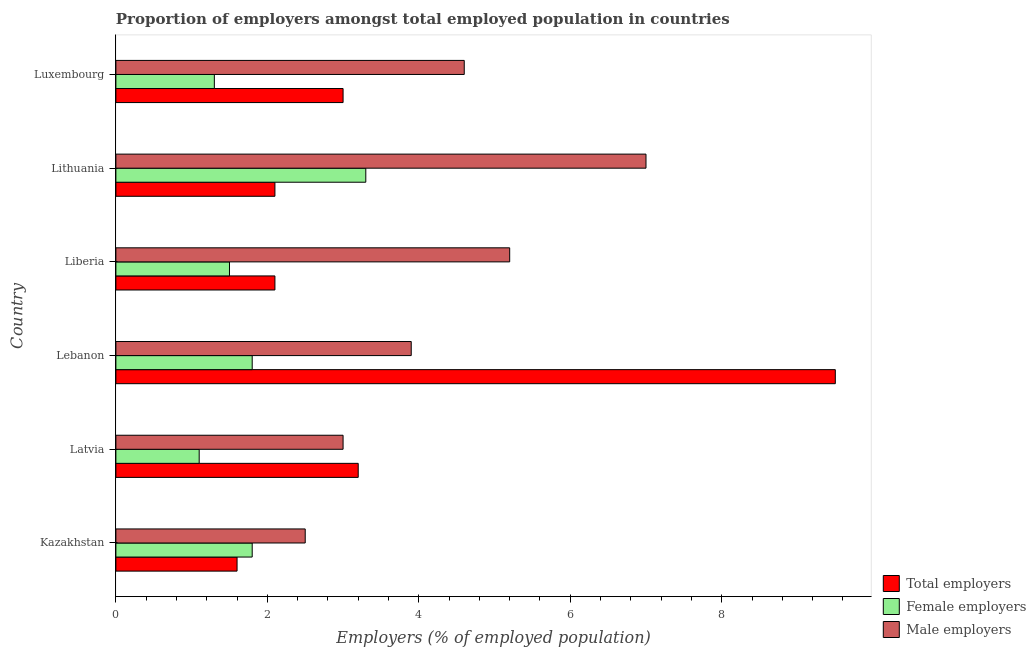How many different coloured bars are there?
Your answer should be compact. 3. Are the number of bars per tick equal to the number of legend labels?
Provide a succinct answer. Yes. Are the number of bars on each tick of the Y-axis equal?
Give a very brief answer. Yes. How many bars are there on the 4th tick from the top?
Give a very brief answer. 3. How many bars are there on the 3rd tick from the bottom?
Your answer should be compact. 3. What is the label of the 6th group of bars from the top?
Give a very brief answer. Kazakhstan. In how many cases, is the number of bars for a given country not equal to the number of legend labels?
Ensure brevity in your answer.  0. What is the percentage of total employers in Kazakhstan?
Your answer should be very brief. 1.6. Across all countries, what is the minimum percentage of male employers?
Offer a terse response. 2.5. In which country was the percentage of female employers maximum?
Keep it short and to the point. Lithuania. In which country was the percentage of female employers minimum?
Your response must be concise. Latvia. What is the total percentage of total employers in the graph?
Offer a terse response. 21.5. What is the difference between the percentage of total employers in Luxembourg and the percentage of male employers in Liberia?
Make the answer very short. -2.2. In how many countries, is the percentage of total employers greater than 7.6 %?
Ensure brevity in your answer.  1. What is the ratio of the percentage of total employers in Kazakhstan to that in Lebanon?
Offer a terse response. 0.17. Is the difference between the percentage of male employers in Liberia and Lithuania greater than the difference between the percentage of female employers in Liberia and Lithuania?
Provide a short and direct response. No. What is the difference between the highest and the second highest percentage of total employers?
Provide a short and direct response. 6.3. What is the difference between the highest and the lowest percentage of female employers?
Offer a very short reply. 2.2. What does the 2nd bar from the top in Lebanon represents?
Make the answer very short. Female employers. What does the 3rd bar from the bottom in Lithuania represents?
Ensure brevity in your answer.  Male employers. Are all the bars in the graph horizontal?
Keep it short and to the point. Yes. Does the graph contain any zero values?
Offer a terse response. No. Where does the legend appear in the graph?
Your answer should be compact. Bottom right. How many legend labels are there?
Make the answer very short. 3. How are the legend labels stacked?
Keep it short and to the point. Vertical. What is the title of the graph?
Ensure brevity in your answer.  Proportion of employers amongst total employed population in countries. What is the label or title of the X-axis?
Make the answer very short. Employers (% of employed population). What is the Employers (% of employed population) of Total employers in Kazakhstan?
Make the answer very short. 1.6. What is the Employers (% of employed population) of Female employers in Kazakhstan?
Give a very brief answer. 1.8. What is the Employers (% of employed population) of Total employers in Latvia?
Your response must be concise. 3.2. What is the Employers (% of employed population) in Female employers in Latvia?
Keep it short and to the point. 1.1. What is the Employers (% of employed population) in Total employers in Lebanon?
Ensure brevity in your answer.  9.5. What is the Employers (% of employed population) in Female employers in Lebanon?
Offer a terse response. 1.8. What is the Employers (% of employed population) of Male employers in Lebanon?
Your response must be concise. 3.9. What is the Employers (% of employed population) of Total employers in Liberia?
Your response must be concise. 2.1. What is the Employers (% of employed population) of Male employers in Liberia?
Your answer should be very brief. 5.2. What is the Employers (% of employed population) in Total employers in Lithuania?
Make the answer very short. 2.1. What is the Employers (% of employed population) in Female employers in Lithuania?
Provide a succinct answer. 3.3. What is the Employers (% of employed population) of Male employers in Lithuania?
Your response must be concise. 7. What is the Employers (% of employed population) in Female employers in Luxembourg?
Provide a short and direct response. 1.3. What is the Employers (% of employed population) of Male employers in Luxembourg?
Ensure brevity in your answer.  4.6. Across all countries, what is the maximum Employers (% of employed population) in Total employers?
Ensure brevity in your answer.  9.5. Across all countries, what is the maximum Employers (% of employed population) of Female employers?
Ensure brevity in your answer.  3.3. Across all countries, what is the minimum Employers (% of employed population) of Total employers?
Provide a short and direct response. 1.6. Across all countries, what is the minimum Employers (% of employed population) of Female employers?
Offer a very short reply. 1.1. Across all countries, what is the minimum Employers (% of employed population) of Male employers?
Give a very brief answer. 2.5. What is the total Employers (% of employed population) of Male employers in the graph?
Your answer should be very brief. 26.2. What is the difference between the Employers (% of employed population) in Total employers in Kazakhstan and that in Latvia?
Make the answer very short. -1.6. What is the difference between the Employers (% of employed population) in Total employers in Kazakhstan and that in Lebanon?
Your answer should be compact. -7.9. What is the difference between the Employers (% of employed population) in Female employers in Kazakhstan and that in Lebanon?
Ensure brevity in your answer.  0. What is the difference between the Employers (% of employed population) in Male employers in Kazakhstan and that in Lebanon?
Your response must be concise. -1.4. What is the difference between the Employers (% of employed population) of Female employers in Kazakhstan and that in Liberia?
Give a very brief answer. 0.3. What is the difference between the Employers (% of employed population) in Total employers in Kazakhstan and that in Lithuania?
Give a very brief answer. -0.5. What is the difference between the Employers (% of employed population) of Female employers in Kazakhstan and that in Lithuania?
Your answer should be very brief. -1.5. What is the difference between the Employers (% of employed population) of Total employers in Kazakhstan and that in Luxembourg?
Provide a short and direct response. -1.4. What is the difference between the Employers (% of employed population) of Female employers in Latvia and that in Lebanon?
Your response must be concise. -0.7. What is the difference between the Employers (% of employed population) of Male employers in Latvia and that in Lebanon?
Offer a terse response. -0.9. What is the difference between the Employers (% of employed population) of Total employers in Latvia and that in Liberia?
Keep it short and to the point. 1.1. What is the difference between the Employers (% of employed population) of Female employers in Latvia and that in Liberia?
Provide a short and direct response. -0.4. What is the difference between the Employers (% of employed population) of Male employers in Latvia and that in Liberia?
Your answer should be very brief. -2.2. What is the difference between the Employers (% of employed population) of Female employers in Latvia and that in Lithuania?
Your answer should be very brief. -2.2. What is the difference between the Employers (% of employed population) of Male employers in Latvia and that in Lithuania?
Your answer should be compact. -4. What is the difference between the Employers (% of employed population) of Total employers in Latvia and that in Luxembourg?
Make the answer very short. 0.2. What is the difference between the Employers (% of employed population) in Male employers in Latvia and that in Luxembourg?
Your response must be concise. -1.6. What is the difference between the Employers (% of employed population) of Total employers in Lebanon and that in Lithuania?
Keep it short and to the point. 7.4. What is the difference between the Employers (% of employed population) in Female employers in Lebanon and that in Lithuania?
Your response must be concise. -1.5. What is the difference between the Employers (% of employed population) in Male employers in Lebanon and that in Lithuania?
Ensure brevity in your answer.  -3.1. What is the difference between the Employers (% of employed population) of Total employers in Lebanon and that in Luxembourg?
Keep it short and to the point. 6.5. What is the difference between the Employers (% of employed population) of Total employers in Liberia and that in Lithuania?
Offer a very short reply. 0. What is the difference between the Employers (% of employed population) of Female employers in Liberia and that in Luxembourg?
Give a very brief answer. 0.2. What is the difference between the Employers (% of employed population) of Male employers in Liberia and that in Luxembourg?
Give a very brief answer. 0.6. What is the difference between the Employers (% of employed population) of Male employers in Lithuania and that in Luxembourg?
Your answer should be compact. 2.4. What is the difference between the Employers (% of employed population) of Total employers in Kazakhstan and the Employers (% of employed population) of Female employers in Latvia?
Make the answer very short. 0.5. What is the difference between the Employers (% of employed population) in Total employers in Kazakhstan and the Employers (% of employed population) in Male employers in Latvia?
Your response must be concise. -1.4. What is the difference between the Employers (% of employed population) of Female employers in Kazakhstan and the Employers (% of employed population) of Male employers in Latvia?
Your answer should be very brief. -1.2. What is the difference between the Employers (% of employed population) in Total employers in Kazakhstan and the Employers (% of employed population) in Female employers in Lebanon?
Make the answer very short. -0.2. What is the difference between the Employers (% of employed population) in Total employers in Kazakhstan and the Employers (% of employed population) in Female employers in Liberia?
Keep it short and to the point. 0.1. What is the difference between the Employers (% of employed population) of Female employers in Kazakhstan and the Employers (% of employed population) of Male employers in Liberia?
Make the answer very short. -3.4. What is the difference between the Employers (% of employed population) in Total employers in Kazakhstan and the Employers (% of employed population) in Female employers in Lithuania?
Provide a succinct answer. -1.7. What is the difference between the Employers (% of employed population) in Total employers in Kazakhstan and the Employers (% of employed population) in Female employers in Luxembourg?
Give a very brief answer. 0.3. What is the difference between the Employers (% of employed population) of Female employers in Kazakhstan and the Employers (% of employed population) of Male employers in Luxembourg?
Your response must be concise. -2.8. What is the difference between the Employers (% of employed population) of Total employers in Latvia and the Employers (% of employed population) of Male employers in Lebanon?
Provide a short and direct response. -0.7. What is the difference between the Employers (% of employed population) in Total employers in Latvia and the Employers (% of employed population) in Female employers in Lithuania?
Your response must be concise. -0.1. What is the difference between the Employers (% of employed population) in Total employers in Latvia and the Employers (% of employed population) in Male employers in Lithuania?
Ensure brevity in your answer.  -3.8. What is the difference between the Employers (% of employed population) of Female employers in Latvia and the Employers (% of employed population) of Male employers in Luxembourg?
Your answer should be compact. -3.5. What is the difference between the Employers (% of employed population) in Female employers in Lebanon and the Employers (% of employed population) in Male employers in Liberia?
Provide a succinct answer. -3.4. What is the difference between the Employers (% of employed population) in Total employers in Lebanon and the Employers (% of employed population) in Female employers in Lithuania?
Make the answer very short. 6.2. What is the difference between the Employers (% of employed population) in Total employers in Lebanon and the Employers (% of employed population) in Male employers in Lithuania?
Provide a succinct answer. 2.5. What is the difference between the Employers (% of employed population) in Female employers in Lebanon and the Employers (% of employed population) in Male employers in Lithuania?
Keep it short and to the point. -5.2. What is the difference between the Employers (% of employed population) in Total employers in Lebanon and the Employers (% of employed population) in Female employers in Luxembourg?
Make the answer very short. 8.2. What is the difference between the Employers (% of employed population) of Total employers in Lebanon and the Employers (% of employed population) of Male employers in Luxembourg?
Your response must be concise. 4.9. What is the difference between the Employers (% of employed population) of Female employers in Lebanon and the Employers (% of employed population) of Male employers in Luxembourg?
Make the answer very short. -2.8. What is the difference between the Employers (% of employed population) of Total employers in Liberia and the Employers (% of employed population) of Male employers in Lithuania?
Give a very brief answer. -4.9. What is the difference between the Employers (% of employed population) in Total employers in Liberia and the Employers (% of employed population) in Female employers in Luxembourg?
Give a very brief answer. 0.8. What is the difference between the Employers (% of employed population) in Total employers in Lithuania and the Employers (% of employed population) in Female employers in Luxembourg?
Offer a terse response. 0.8. What is the difference between the Employers (% of employed population) of Total employers in Lithuania and the Employers (% of employed population) of Male employers in Luxembourg?
Keep it short and to the point. -2.5. What is the difference between the Employers (% of employed population) in Female employers in Lithuania and the Employers (% of employed population) in Male employers in Luxembourg?
Ensure brevity in your answer.  -1.3. What is the average Employers (% of employed population) of Total employers per country?
Your answer should be very brief. 3.58. What is the average Employers (% of employed population) of Female employers per country?
Ensure brevity in your answer.  1.8. What is the average Employers (% of employed population) of Male employers per country?
Provide a succinct answer. 4.37. What is the difference between the Employers (% of employed population) of Total employers and Employers (% of employed population) of Female employers in Kazakhstan?
Keep it short and to the point. -0.2. What is the difference between the Employers (% of employed population) in Female employers and Employers (% of employed population) in Male employers in Kazakhstan?
Offer a very short reply. -0.7. What is the difference between the Employers (% of employed population) in Total employers and Employers (% of employed population) in Male employers in Latvia?
Provide a short and direct response. 0.2. What is the difference between the Employers (% of employed population) in Female employers and Employers (% of employed population) in Male employers in Latvia?
Provide a succinct answer. -1.9. What is the difference between the Employers (% of employed population) in Total employers and Employers (% of employed population) in Male employers in Lithuania?
Your response must be concise. -4.9. What is the difference between the Employers (% of employed population) of Female employers and Employers (% of employed population) of Male employers in Lithuania?
Offer a terse response. -3.7. What is the difference between the Employers (% of employed population) of Total employers and Employers (% of employed population) of Female employers in Luxembourg?
Make the answer very short. 1.7. What is the difference between the Employers (% of employed population) in Female employers and Employers (% of employed population) in Male employers in Luxembourg?
Give a very brief answer. -3.3. What is the ratio of the Employers (% of employed population) in Total employers in Kazakhstan to that in Latvia?
Provide a short and direct response. 0.5. What is the ratio of the Employers (% of employed population) of Female employers in Kazakhstan to that in Latvia?
Provide a short and direct response. 1.64. What is the ratio of the Employers (% of employed population) in Total employers in Kazakhstan to that in Lebanon?
Provide a short and direct response. 0.17. What is the ratio of the Employers (% of employed population) of Female employers in Kazakhstan to that in Lebanon?
Keep it short and to the point. 1. What is the ratio of the Employers (% of employed population) of Male employers in Kazakhstan to that in Lebanon?
Your response must be concise. 0.64. What is the ratio of the Employers (% of employed population) of Total employers in Kazakhstan to that in Liberia?
Offer a very short reply. 0.76. What is the ratio of the Employers (% of employed population) in Female employers in Kazakhstan to that in Liberia?
Your answer should be very brief. 1.2. What is the ratio of the Employers (% of employed population) in Male employers in Kazakhstan to that in Liberia?
Give a very brief answer. 0.48. What is the ratio of the Employers (% of employed population) in Total employers in Kazakhstan to that in Lithuania?
Give a very brief answer. 0.76. What is the ratio of the Employers (% of employed population) of Female employers in Kazakhstan to that in Lithuania?
Ensure brevity in your answer.  0.55. What is the ratio of the Employers (% of employed population) in Male employers in Kazakhstan to that in Lithuania?
Ensure brevity in your answer.  0.36. What is the ratio of the Employers (% of employed population) of Total employers in Kazakhstan to that in Luxembourg?
Keep it short and to the point. 0.53. What is the ratio of the Employers (% of employed population) of Female employers in Kazakhstan to that in Luxembourg?
Offer a terse response. 1.38. What is the ratio of the Employers (% of employed population) of Male employers in Kazakhstan to that in Luxembourg?
Your answer should be very brief. 0.54. What is the ratio of the Employers (% of employed population) in Total employers in Latvia to that in Lebanon?
Make the answer very short. 0.34. What is the ratio of the Employers (% of employed population) in Female employers in Latvia to that in Lebanon?
Your response must be concise. 0.61. What is the ratio of the Employers (% of employed population) in Male employers in Latvia to that in Lebanon?
Make the answer very short. 0.77. What is the ratio of the Employers (% of employed population) in Total employers in Latvia to that in Liberia?
Provide a succinct answer. 1.52. What is the ratio of the Employers (% of employed population) of Female employers in Latvia to that in Liberia?
Provide a succinct answer. 0.73. What is the ratio of the Employers (% of employed population) of Male employers in Latvia to that in Liberia?
Give a very brief answer. 0.58. What is the ratio of the Employers (% of employed population) of Total employers in Latvia to that in Lithuania?
Provide a succinct answer. 1.52. What is the ratio of the Employers (% of employed population) of Female employers in Latvia to that in Lithuania?
Keep it short and to the point. 0.33. What is the ratio of the Employers (% of employed population) of Male employers in Latvia to that in Lithuania?
Give a very brief answer. 0.43. What is the ratio of the Employers (% of employed population) of Total employers in Latvia to that in Luxembourg?
Your answer should be very brief. 1.07. What is the ratio of the Employers (% of employed population) of Female employers in Latvia to that in Luxembourg?
Offer a terse response. 0.85. What is the ratio of the Employers (% of employed population) in Male employers in Latvia to that in Luxembourg?
Make the answer very short. 0.65. What is the ratio of the Employers (% of employed population) in Total employers in Lebanon to that in Liberia?
Ensure brevity in your answer.  4.52. What is the ratio of the Employers (% of employed population) in Female employers in Lebanon to that in Liberia?
Offer a very short reply. 1.2. What is the ratio of the Employers (% of employed population) in Male employers in Lebanon to that in Liberia?
Your answer should be compact. 0.75. What is the ratio of the Employers (% of employed population) of Total employers in Lebanon to that in Lithuania?
Provide a succinct answer. 4.52. What is the ratio of the Employers (% of employed population) of Female employers in Lebanon to that in Lithuania?
Make the answer very short. 0.55. What is the ratio of the Employers (% of employed population) of Male employers in Lebanon to that in Lithuania?
Keep it short and to the point. 0.56. What is the ratio of the Employers (% of employed population) of Total employers in Lebanon to that in Luxembourg?
Provide a succinct answer. 3.17. What is the ratio of the Employers (% of employed population) of Female employers in Lebanon to that in Luxembourg?
Give a very brief answer. 1.38. What is the ratio of the Employers (% of employed population) of Male employers in Lebanon to that in Luxembourg?
Ensure brevity in your answer.  0.85. What is the ratio of the Employers (% of employed population) in Female employers in Liberia to that in Lithuania?
Your answer should be very brief. 0.45. What is the ratio of the Employers (% of employed population) in Male employers in Liberia to that in Lithuania?
Ensure brevity in your answer.  0.74. What is the ratio of the Employers (% of employed population) of Female employers in Liberia to that in Luxembourg?
Ensure brevity in your answer.  1.15. What is the ratio of the Employers (% of employed population) in Male employers in Liberia to that in Luxembourg?
Provide a short and direct response. 1.13. What is the ratio of the Employers (% of employed population) of Female employers in Lithuania to that in Luxembourg?
Your answer should be compact. 2.54. What is the ratio of the Employers (% of employed population) in Male employers in Lithuania to that in Luxembourg?
Provide a succinct answer. 1.52. What is the difference between the highest and the second highest Employers (% of employed population) in Total employers?
Provide a succinct answer. 6.3. What is the difference between the highest and the lowest Employers (% of employed population) in Total employers?
Offer a very short reply. 7.9. What is the difference between the highest and the lowest Employers (% of employed population) of Male employers?
Your answer should be compact. 4.5. 